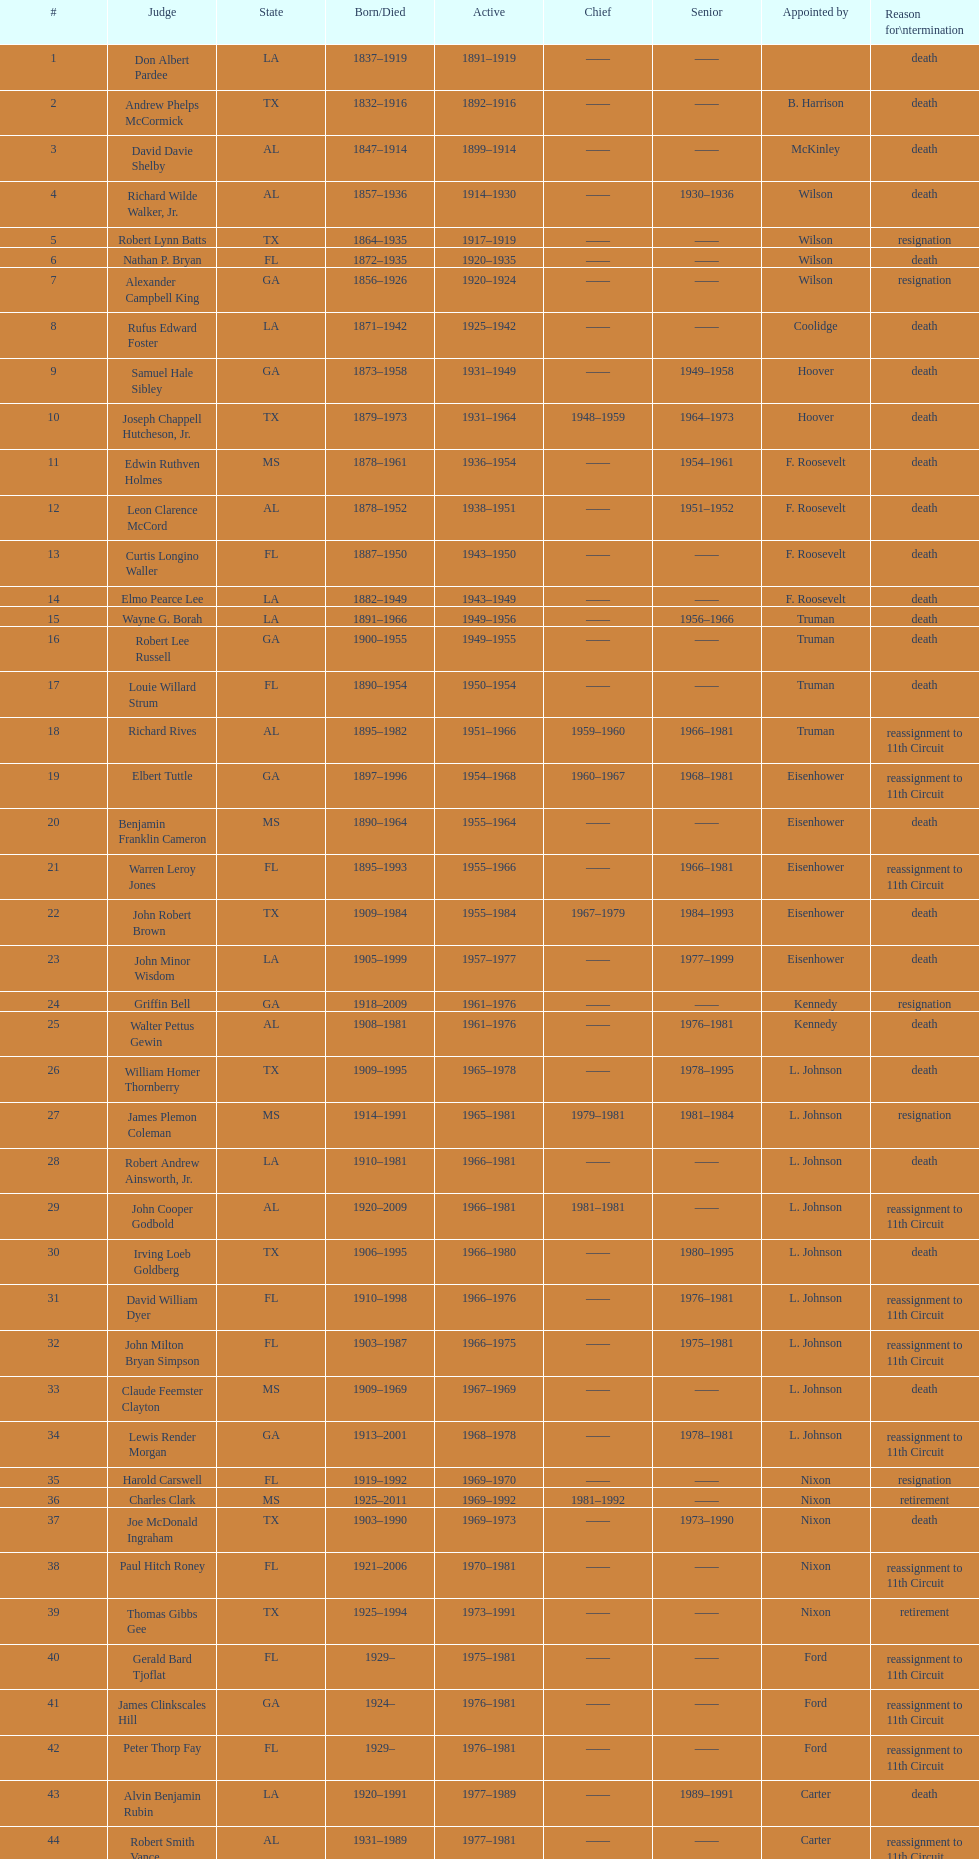How many judges were appointed by president carter? 13. 